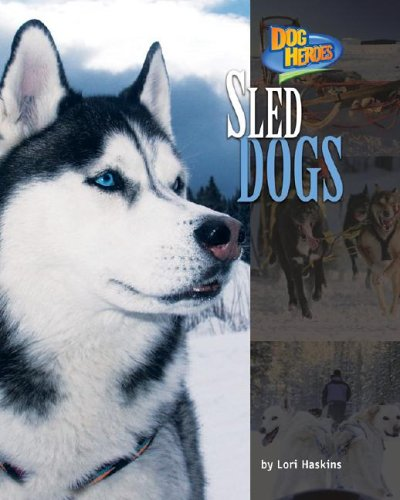Can you tell me more about sled dogs and why they are considered heroes? Sled dogs are renowned for their strength, endurance, and ability to navigate harsh winter terrains. They are considered heroes due to their life-saving roles in transportation and rescue missions in snowy regions, most famously the 1925 serum run to Nome, Alaska. 